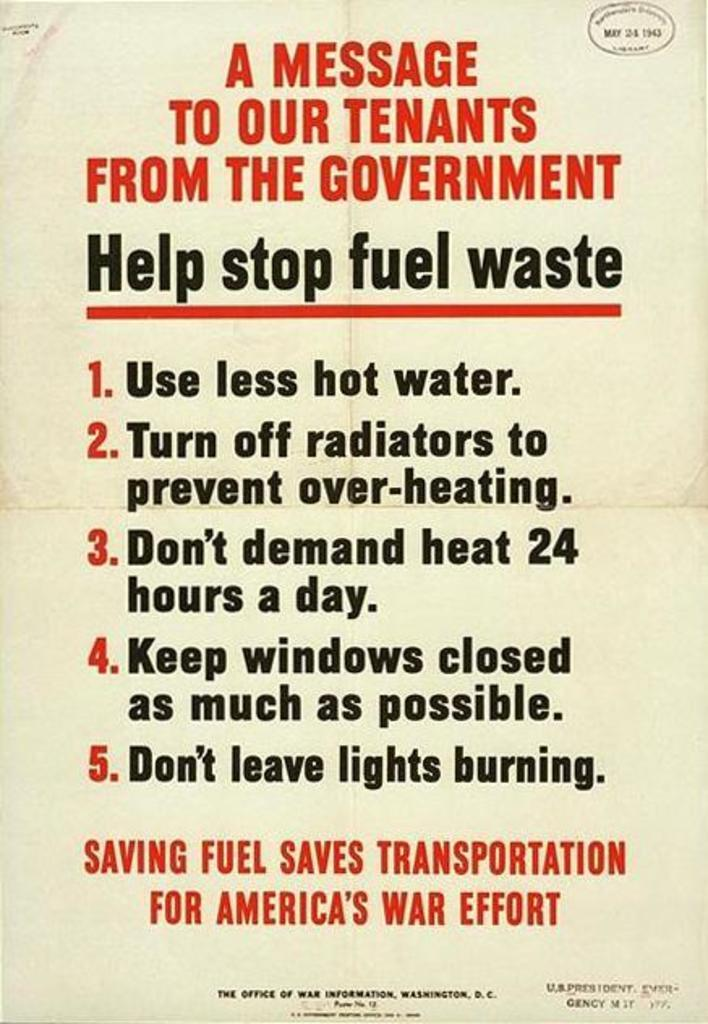<image>
Provide a brief description of the given image. A sign with a message to help stop fuel waste. 